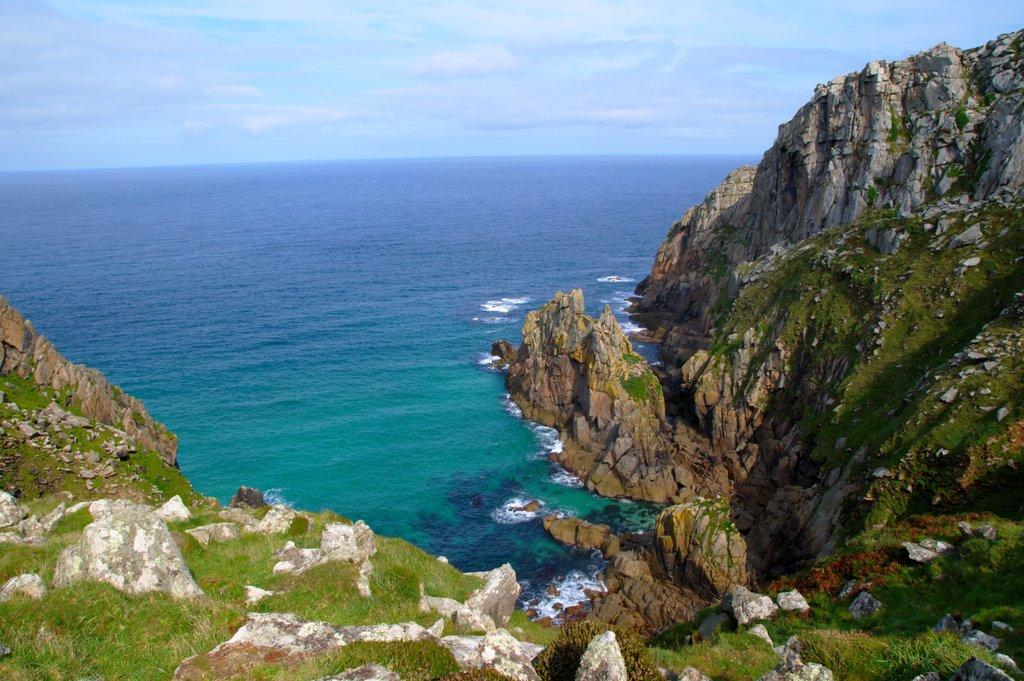What type of terrain is in the front of the image? There are rocky mountains in the front of the image. What can be seen in the background of the image? Water, clouds, and the sky are visible in the background of the image. Can you describe the sky in the image? The sky is visible in the background of the image. What type of toys can be seen floating in the water in the image? There are no toys present in the image; it features rocky mountains, water, clouds, and the sky. How many nails are visible in the image? There are no nails visible in the image. 